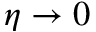<formula> <loc_0><loc_0><loc_500><loc_500>\eta \rightarrow 0</formula> 